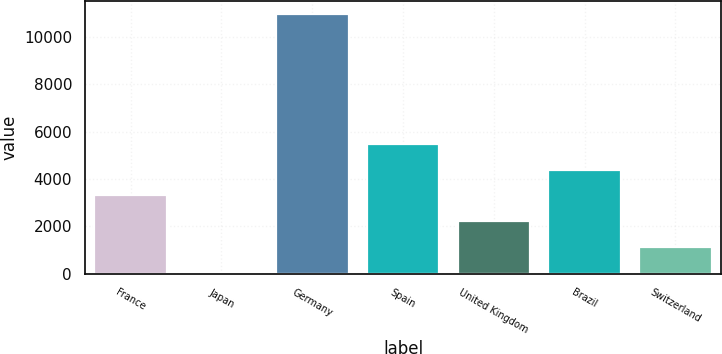Convert chart to OTSL. <chart><loc_0><loc_0><loc_500><loc_500><bar_chart><fcel>France<fcel>Japan<fcel>Germany<fcel>Spain<fcel>United Kingdom<fcel>Brazil<fcel>Switzerland<nl><fcel>3306.1<fcel>19<fcel>10976<fcel>5497.5<fcel>2210.4<fcel>4401.8<fcel>1114.7<nl></chart> 